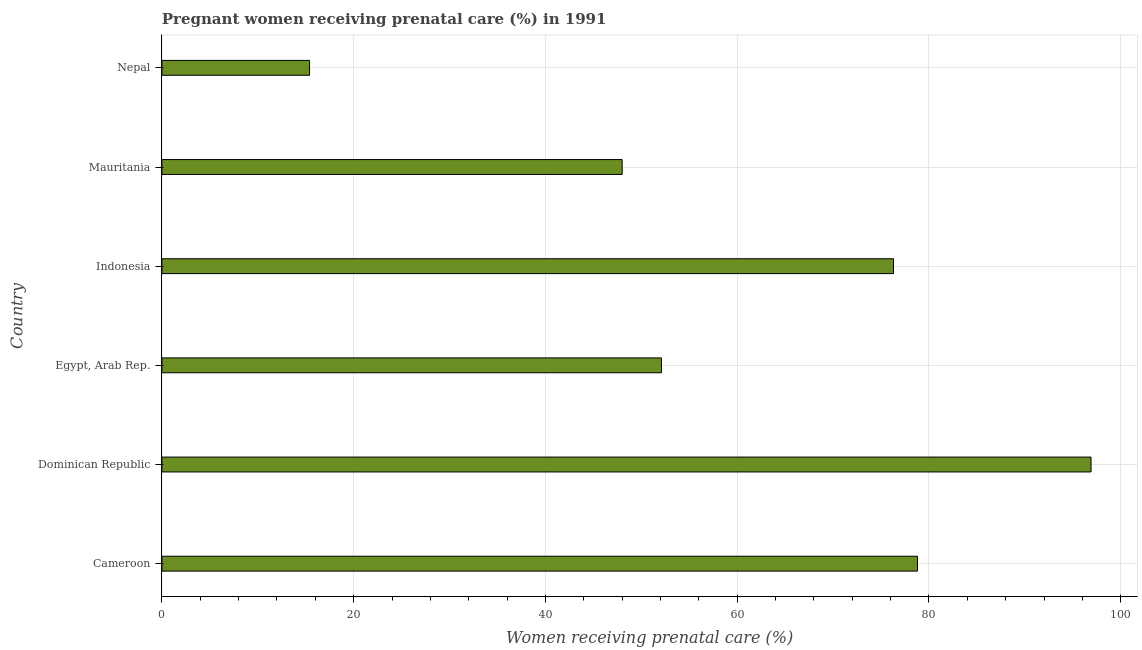Does the graph contain grids?
Your response must be concise. Yes. What is the title of the graph?
Ensure brevity in your answer.  Pregnant women receiving prenatal care (%) in 1991. What is the label or title of the X-axis?
Make the answer very short. Women receiving prenatal care (%). What is the label or title of the Y-axis?
Your answer should be compact. Country. Across all countries, what is the maximum percentage of pregnant women receiving prenatal care?
Offer a terse response. 96.9. Across all countries, what is the minimum percentage of pregnant women receiving prenatal care?
Provide a short and direct response. 15.4. In which country was the percentage of pregnant women receiving prenatal care maximum?
Provide a short and direct response. Dominican Republic. In which country was the percentage of pregnant women receiving prenatal care minimum?
Your response must be concise. Nepal. What is the sum of the percentage of pregnant women receiving prenatal care?
Your response must be concise. 367.5. What is the average percentage of pregnant women receiving prenatal care per country?
Keep it short and to the point. 61.25. What is the median percentage of pregnant women receiving prenatal care?
Ensure brevity in your answer.  64.2. In how many countries, is the percentage of pregnant women receiving prenatal care greater than 80 %?
Ensure brevity in your answer.  1. What is the ratio of the percentage of pregnant women receiving prenatal care in Indonesia to that in Mauritania?
Offer a very short reply. 1.59. Is the percentage of pregnant women receiving prenatal care in Egypt, Arab Rep. less than that in Nepal?
Offer a very short reply. No. Is the difference between the percentage of pregnant women receiving prenatal care in Egypt, Arab Rep. and Nepal greater than the difference between any two countries?
Give a very brief answer. No. What is the difference between the highest and the lowest percentage of pregnant women receiving prenatal care?
Your answer should be compact. 81.5. How many bars are there?
Provide a short and direct response. 6. Are all the bars in the graph horizontal?
Your response must be concise. Yes. How many countries are there in the graph?
Offer a terse response. 6. Are the values on the major ticks of X-axis written in scientific E-notation?
Your answer should be compact. No. What is the Women receiving prenatal care (%) of Cameroon?
Your answer should be compact. 78.8. What is the Women receiving prenatal care (%) in Dominican Republic?
Make the answer very short. 96.9. What is the Women receiving prenatal care (%) of Egypt, Arab Rep.?
Offer a very short reply. 52.1. What is the Women receiving prenatal care (%) in Indonesia?
Your answer should be compact. 76.3. What is the Women receiving prenatal care (%) in Mauritania?
Keep it short and to the point. 48. What is the Women receiving prenatal care (%) in Nepal?
Ensure brevity in your answer.  15.4. What is the difference between the Women receiving prenatal care (%) in Cameroon and Dominican Republic?
Your answer should be very brief. -18.1. What is the difference between the Women receiving prenatal care (%) in Cameroon and Egypt, Arab Rep.?
Provide a short and direct response. 26.7. What is the difference between the Women receiving prenatal care (%) in Cameroon and Mauritania?
Offer a very short reply. 30.8. What is the difference between the Women receiving prenatal care (%) in Cameroon and Nepal?
Keep it short and to the point. 63.4. What is the difference between the Women receiving prenatal care (%) in Dominican Republic and Egypt, Arab Rep.?
Provide a succinct answer. 44.8. What is the difference between the Women receiving prenatal care (%) in Dominican Republic and Indonesia?
Offer a terse response. 20.6. What is the difference between the Women receiving prenatal care (%) in Dominican Republic and Mauritania?
Give a very brief answer. 48.9. What is the difference between the Women receiving prenatal care (%) in Dominican Republic and Nepal?
Your response must be concise. 81.5. What is the difference between the Women receiving prenatal care (%) in Egypt, Arab Rep. and Indonesia?
Give a very brief answer. -24.2. What is the difference between the Women receiving prenatal care (%) in Egypt, Arab Rep. and Nepal?
Offer a very short reply. 36.7. What is the difference between the Women receiving prenatal care (%) in Indonesia and Mauritania?
Provide a succinct answer. 28.3. What is the difference between the Women receiving prenatal care (%) in Indonesia and Nepal?
Ensure brevity in your answer.  60.9. What is the difference between the Women receiving prenatal care (%) in Mauritania and Nepal?
Provide a short and direct response. 32.6. What is the ratio of the Women receiving prenatal care (%) in Cameroon to that in Dominican Republic?
Make the answer very short. 0.81. What is the ratio of the Women receiving prenatal care (%) in Cameroon to that in Egypt, Arab Rep.?
Your answer should be compact. 1.51. What is the ratio of the Women receiving prenatal care (%) in Cameroon to that in Indonesia?
Your answer should be compact. 1.03. What is the ratio of the Women receiving prenatal care (%) in Cameroon to that in Mauritania?
Make the answer very short. 1.64. What is the ratio of the Women receiving prenatal care (%) in Cameroon to that in Nepal?
Offer a terse response. 5.12. What is the ratio of the Women receiving prenatal care (%) in Dominican Republic to that in Egypt, Arab Rep.?
Keep it short and to the point. 1.86. What is the ratio of the Women receiving prenatal care (%) in Dominican Republic to that in Indonesia?
Provide a short and direct response. 1.27. What is the ratio of the Women receiving prenatal care (%) in Dominican Republic to that in Mauritania?
Your answer should be very brief. 2.02. What is the ratio of the Women receiving prenatal care (%) in Dominican Republic to that in Nepal?
Keep it short and to the point. 6.29. What is the ratio of the Women receiving prenatal care (%) in Egypt, Arab Rep. to that in Indonesia?
Offer a very short reply. 0.68. What is the ratio of the Women receiving prenatal care (%) in Egypt, Arab Rep. to that in Mauritania?
Provide a short and direct response. 1.08. What is the ratio of the Women receiving prenatal care (%) in Egypt, Arab Rep. to that in Nepal?
Offer a terse response. 3.38. What is the ratio of the Women receiving prenatal care (%) in Indonesia to that in Mauritania?
Offer a terse response. 1.59. What is the ratio of the Women receiving prenatal care (%) in Indonesia to that in Nepal?
Make the answer very short. 4.96. What is the ratio of the Women receiving prenatal care (%) in Mauritania to that in Nepal?
Give a very brief answer. 3.12. 